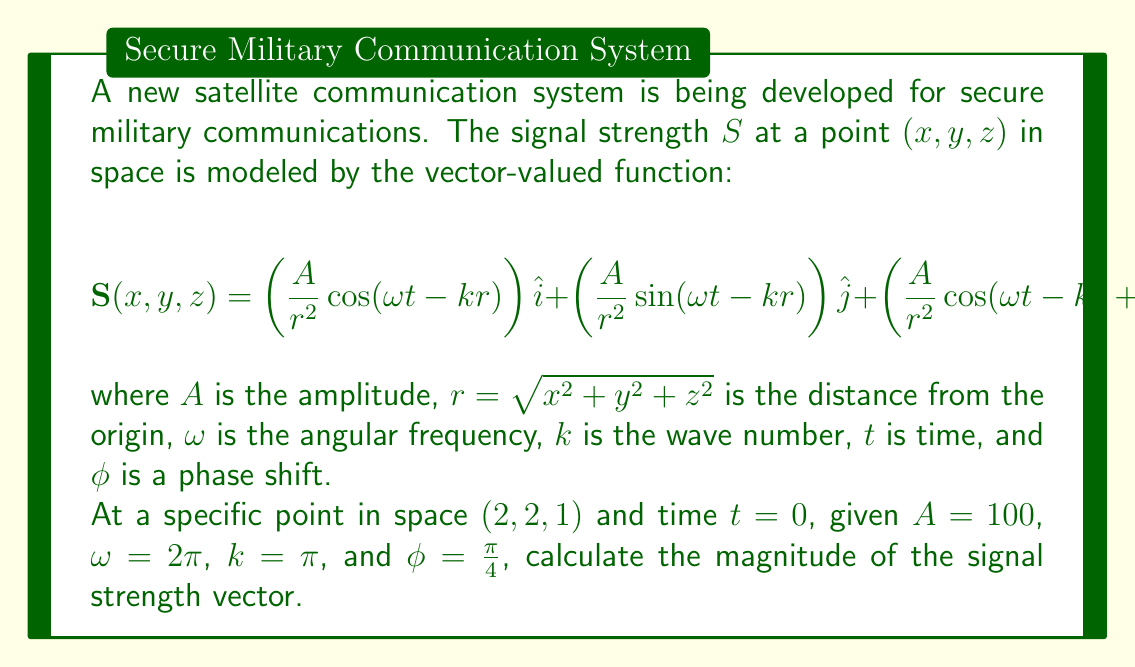Teach me how to tackle this problem. To solve this problem, we'll follow these steps:

1) First, we need to calculate $r$ at the given point $(2, 2, 1)$:

   $$r = \sqrt{2^2 + 2^2 + 1^2} = \sqrt{4 + 4 + 1} = \sqrt{9} = 3$$

2) Now, we can substitute the given values into the vector function:

   $$\mathbf{S}(2, 2, 1) = \left(\frac{100}{3^2}\cos(2\pi \cdot 0 - \pi \cdot 3)\right)\hat{i} + \left(\frac{100}{3^2}\sin(2\pi \cdot 0 - \pi \cdot 3)\right)\hat{j} + \left(\frac{100}{3^2}\cos(2\pi \cdot 0 - \pi \cdot 3 + \frac{\pi}{4})\right)\hat{k}$$

3) Simplify:

   $$\mathbf{S}(2, 2, 1) = \left(\frac{100}{9}\cos(-3\pi)\right)\hat{i} + \left(\frac{100}{9}\sin(-3\pi)\right)\hat{j} + \left(\frac{100}{9}\cos(-3\pi + \frac{\pi}{4})\right)\hat{k}$$

4) Calculate the trigonometric functions:

   $\cos(-3\pi) = -1$
   $\sin(-3\pi) = 0$
   $\cos(-3\pi + \frac{\pi}{4}) = -\frac{\sqrt{2}}{2}$

5) Substitute these values:

   $$\mathbf{S}(2, 2, 1) = -\frac{100}{9}\hat{i} + 0\hat{j} - \frac{100\sqrt{2}}{18}\hat{k}$$

6) To find the magnitude of this vector, we use the formula $|\mathbf{S}| = \sqrt{S_x^2 + S_y^2 + S_z^2}$:

   $$|\mathbf{S}| = \sqrt{\left(-\frac{100}{9}\right)^2 + 0^2 + \left(-\frac{100\sqrt{2}}{18}\right)^2}$$

7) Simplify under the square root:

   $$|\mathbf{S}| = \sqrt{\frac{10000}{81} + \frac{10000}{162}} = \sqrt{\frac{20000}{162}} = \sqrt{\frac{10000}{81}} = \frac{100}{9}\sqrt{1 + \frac{1}{2}} = \frac{100}{9}\sqrt{\frac{3}{2}}$$

8) This can be further simplified:

   $$|\mathbf{S}| = \frac{100\sqrt{6}}{18} = \frac{50\sqrt{6}}{9}$$
Answer: $\frac{50\sqrt{6}}{9}$ 